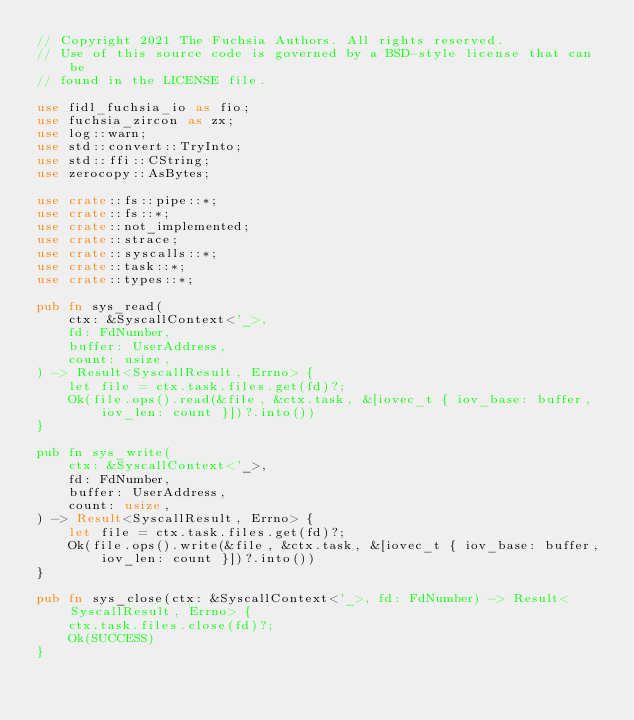Convert code to text. <code><loc_0><loc_0><loc_500><loc_500><_Rust_>// Copyright 2021 The Fuchsia Authors. All rights reserved.
// Use of this source code is governed by a BSD-style license that can be
// found in the LICENSE file.

use fidl_fuchsia_io as fio;
use fuchsia_zircon as zx;
use log::warn;
use std::convert::TryInto;
use std::ffi::CString;
use zerocopy::AsBytes;

use crate::fs::pipe::*;
use crate::fs::*;
use crate::not_implemented;
use crate::strace;
use crate::syscalls::*;
use crate::task::*;
use crate::types::*;

pub fn sys_read(
    ctx: &SyscallContext<'_>,
    fd: FdNumber,
    buffer: UserAddress,
    count: usize,
) -> Result<SyscallResult, Errno> {
    let file = ctx.task.files.get(fd)?;
    Ok(file.ops().read(&file, &ctx.task, &[iovec_t { iov_base: buffer, iov_len: count }])?.into())
}

pub fn sys_write(
    ctx: &SyscallContext<'_>,
    fd: FdNumber,
    buffer: UserAddress,
    count: usize,
) -> Result<SyscallResult, Errno> {
    let file = ctx.task.files.get(fd)?;
    Ok(file.ops().write(&file, &ctx.task, &[iovec_t { iov_base: buffer, iov_len: count }])?.into())
}

pub fn sys_close(ctx: &SyscallContext<'_>, fd: FdNumber) -> Result<SyscallResult, Errno> {
    ctx.task.files.close(fd)?;
    Ok(SUCCESS)
}
</code> 